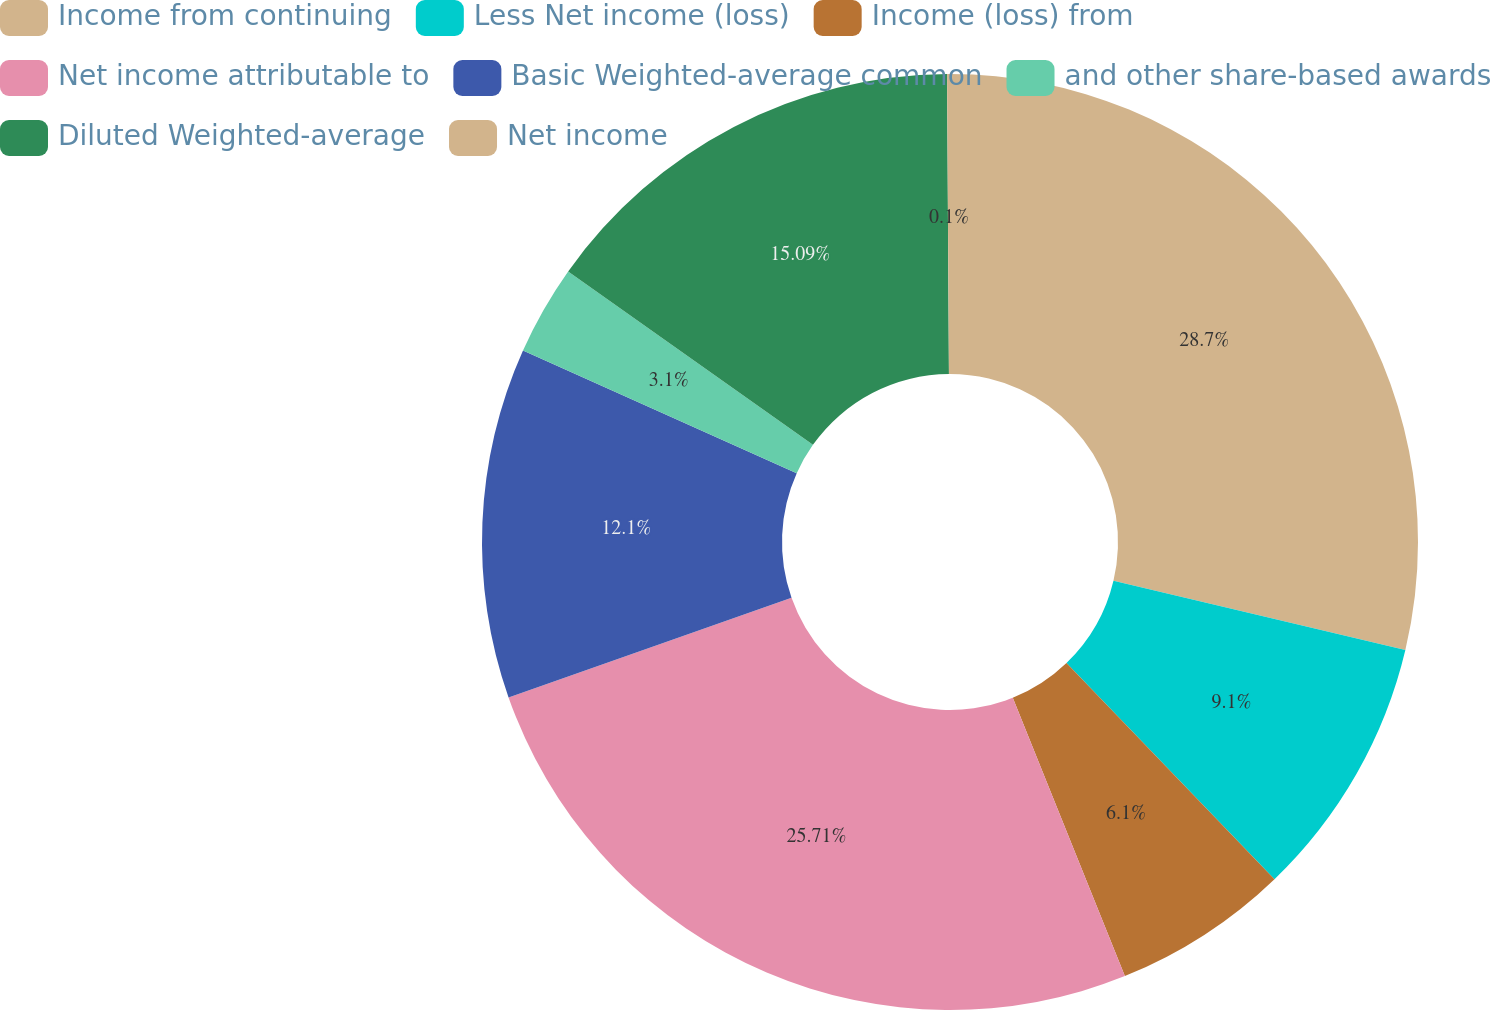Convert chart. <chart><loc_0><loc_0><loc_500><loc_500><pie_chart><fcel>Income from continuing<fcel>Less Net income (loss)<fcel>Income (loss) from<fcel>Net income attributable to<fcel>Basic Weighted-average common<fcel>and other share-based awards<fcel>Diluted Weighted-average<fcel>Net income<nl><fcel>28.71%<fcel>9.1%<fcel>6.1%<fcel>25.71%<fcel>12.1%<fcel>3.1%<fcel>15.09%<fcel>0.1%<nl></chart> 